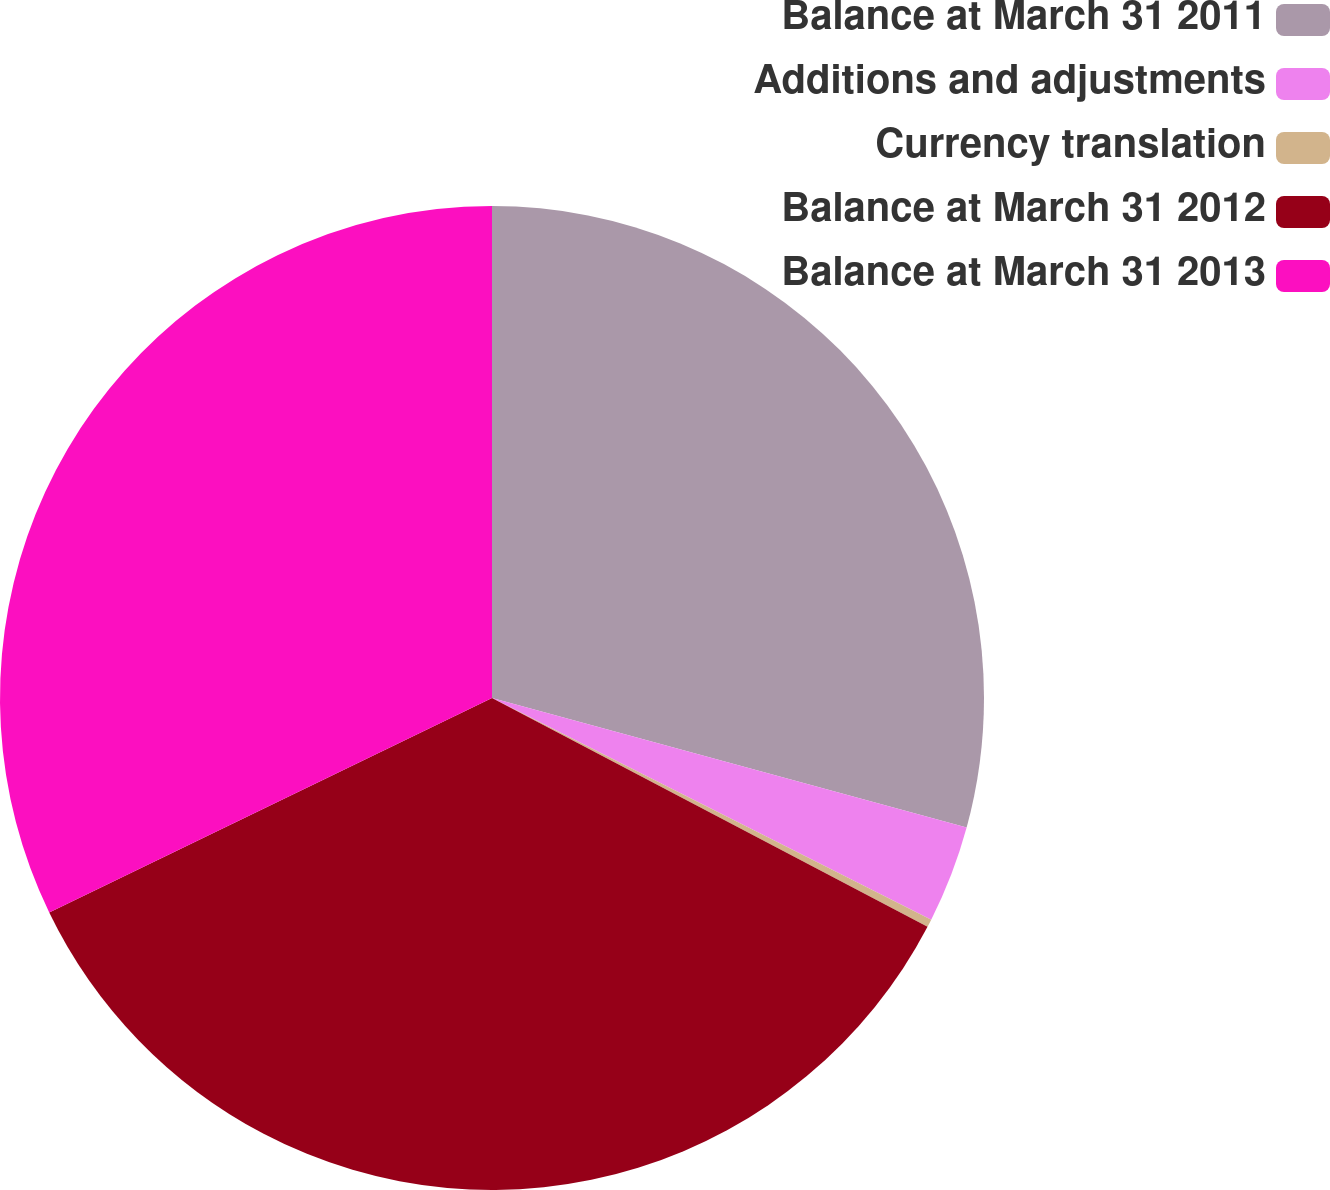Convert chart. <chart><loc_0><loc_0><loc_500><loc_500><pie_chart><fcel>Balance at March 31 2011<fcel>Additions and adjustments<fcel>Currency translation<fcel>Balance at March 31 2012<fcel>Balance at March 31 2013<nl><fcel>29.24%<fcel>3.2%<fcel>0.26%<fcel>35.12%<fcel>32.18%<nl></chart> 